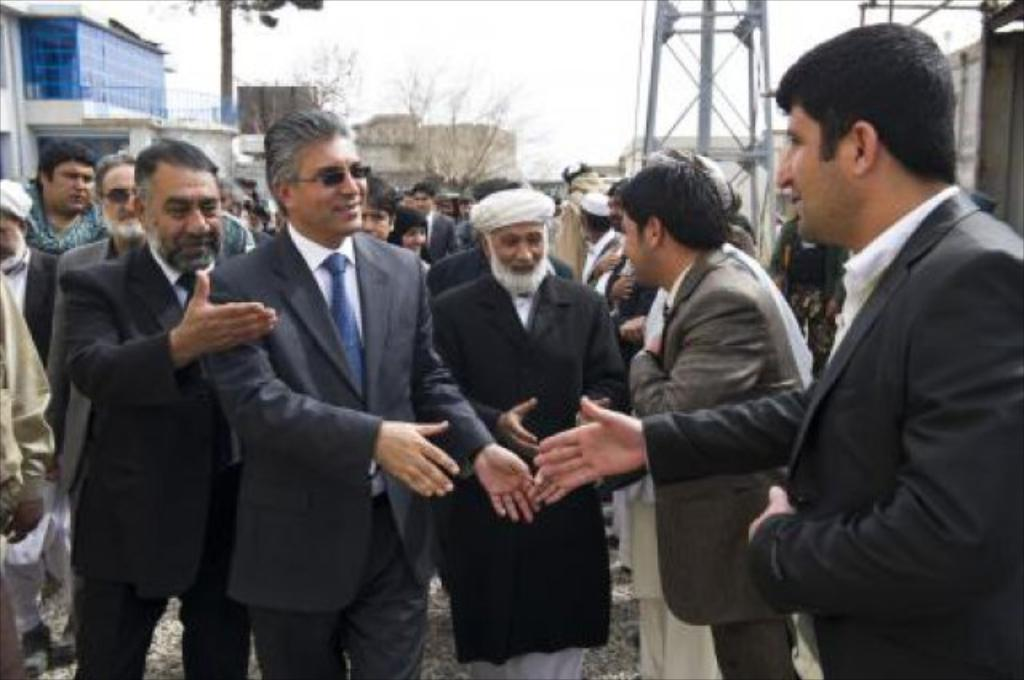What is the main subject of the image? The main subject of the image is a crowd of people. Where are the people standing in the image? The people are standing on the ground. Can you describe the expressions of some people in the crowd? Some men in the crowd are smiling. What can be seen in the background of the image? There are buildings, trees, and poles in the background of the image. What is visible at the top of the image? The sky is visible at the top of the image. Can you tell me how many dogs are running in the image? There are no dogs present in the image; it features a crowd of people. What type of deer can be seen in the background of the image? There are no deer present in the image; it features buildings, trees, and poles in the background. 